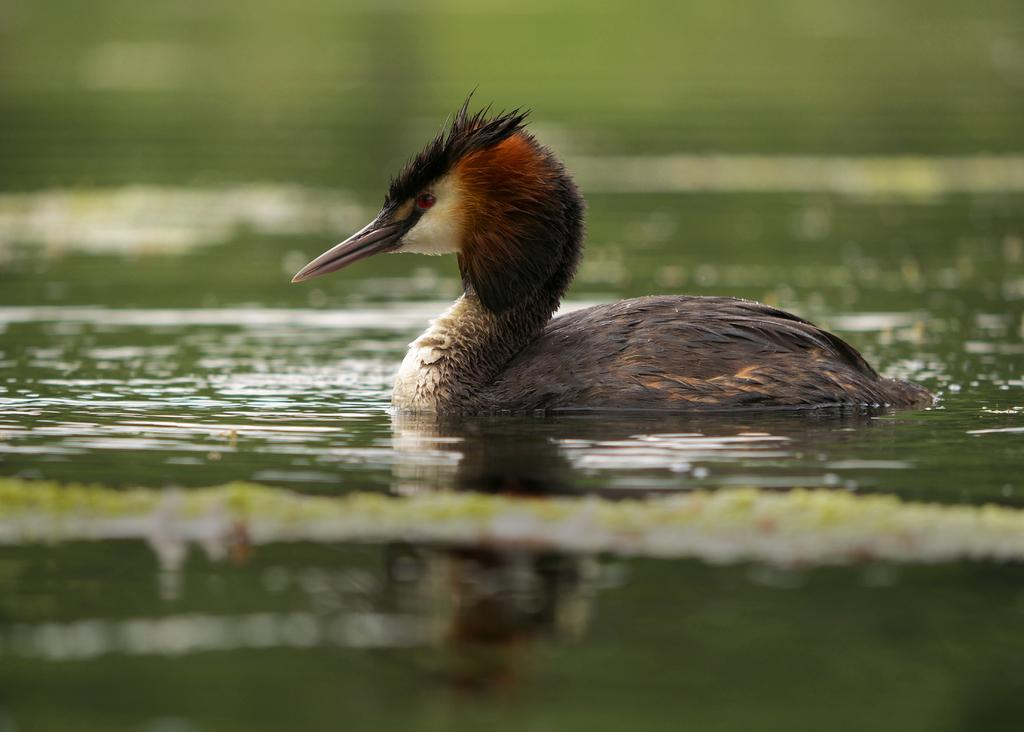What is visible in the image? Water is visible in the image. What can be seen on the water in the image? There is a brown-colored bird on the water in the image. How many tomatoes can be seen being shaken by the bird in the image? There are no tomatoes present in the image, and the bird is not shaking anything. What type of fork is the bird using to eat in the image? There is no fork present in the image, and the bird is not eating anything. 